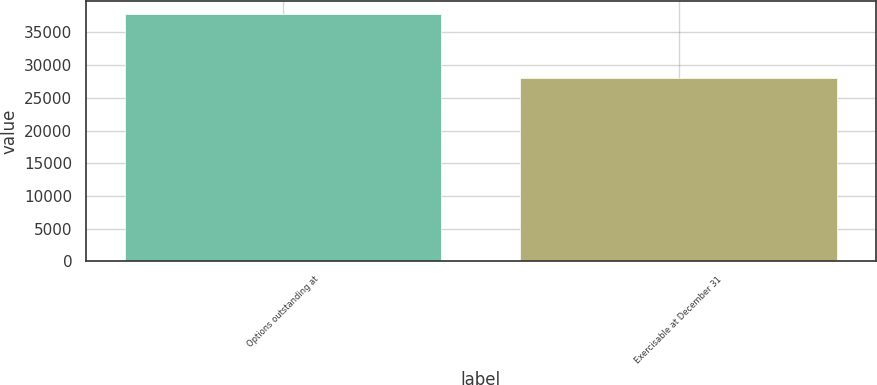Convert chart to OTSL. <chart><loc_0><loc_0><loc_500><loc_500><bar_chart><fcel>Options outstanding at<fcel>Exercisable at December 31<nl><fcel>37881<fcel>28022<nl></chart> 